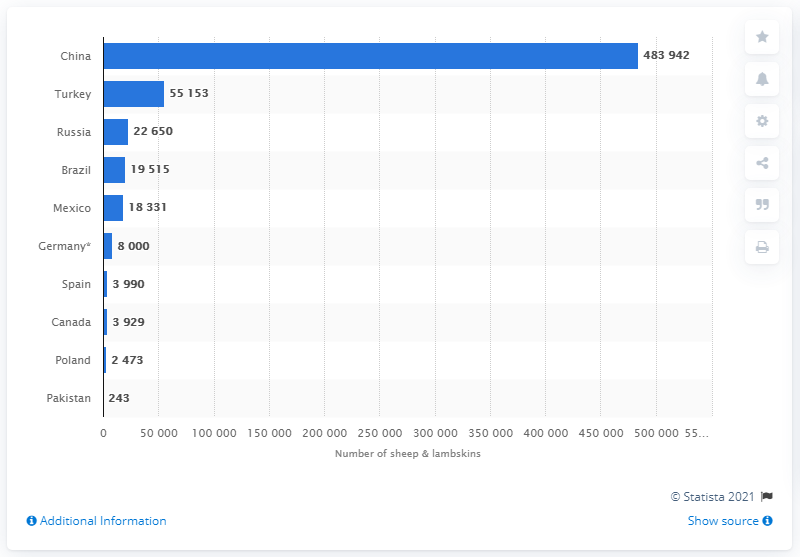Point out several critical features in this image. Mexico was the fifth largest exporter of sheep and lambskins to the United States in 2019. The United States exported 18,331 sheep and lambskins to Mexico in 2019. 